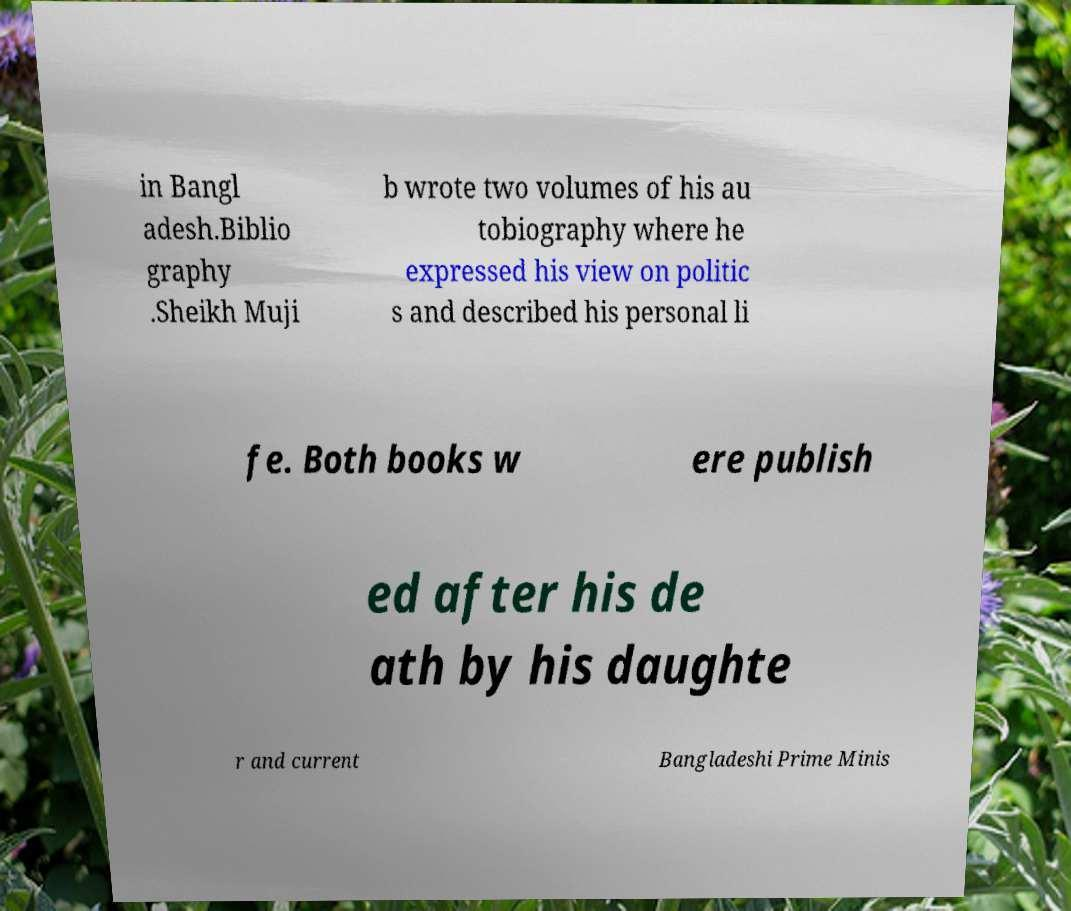Can you accurately transcribe the text from the provided image for me? in Bangl adesh.Biblio graphy .Sheikh Muji b wrote two volumes of his au tobiography where he expressed his view on politic s and described his personal li fe. Both books w ere publish ed after his de ath by his daughte r and current Bangladeshi Prime Minis 